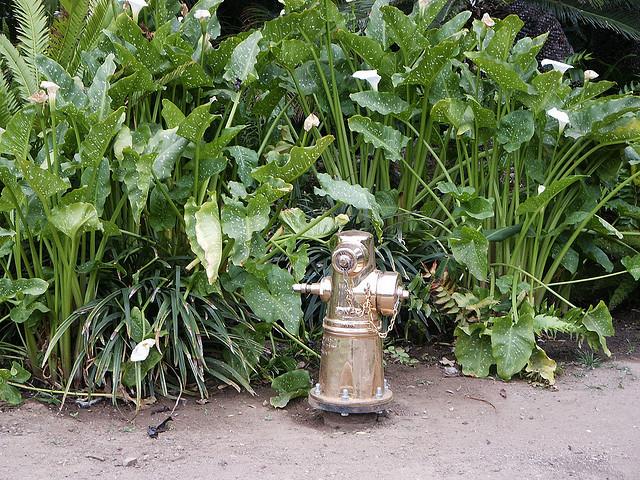What is gold?
Concise answer only. Fire hydrant. What is behind the fire hydrant?
Be succinct. Plants. Is this fire hydrant red?
Keep it brief. No. 